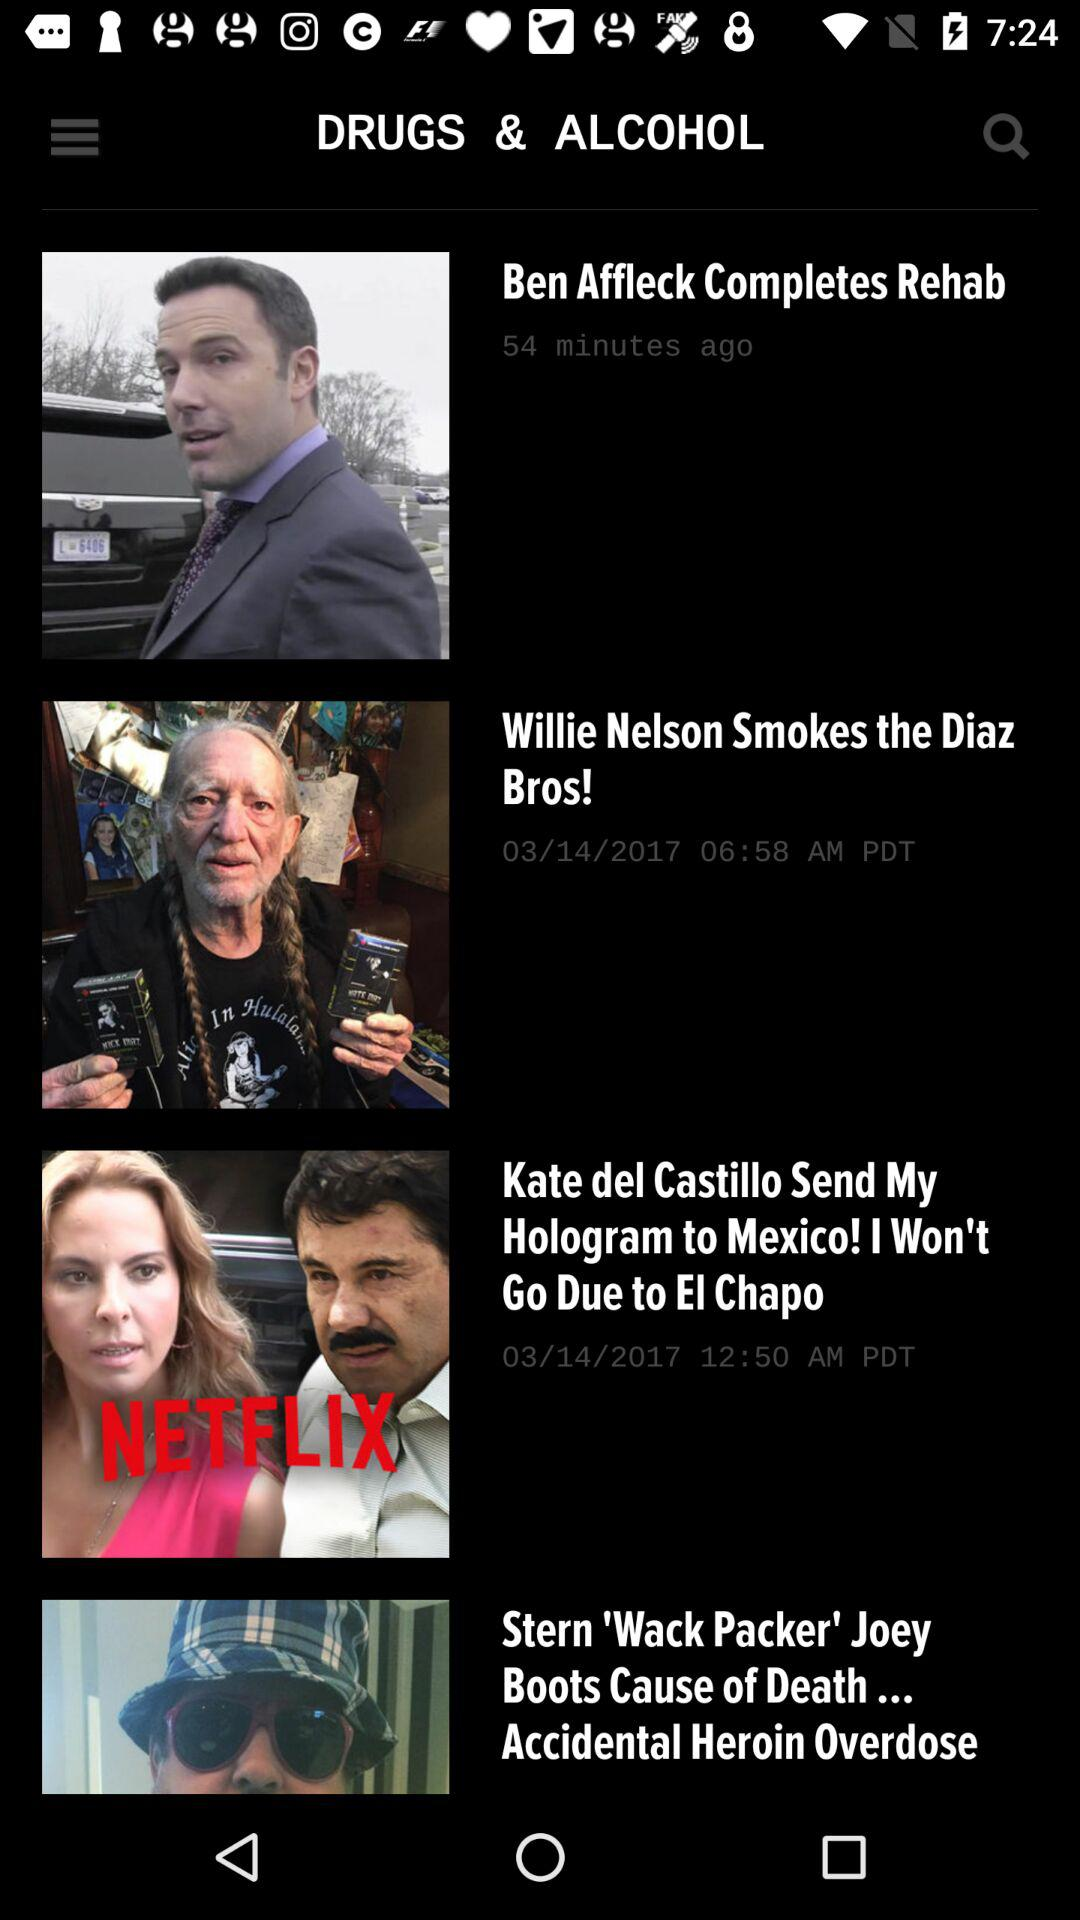How long ago was the "Ben Affleck Completes Rehab" news uploaded? The news was uploaded 54 minutes ago. 